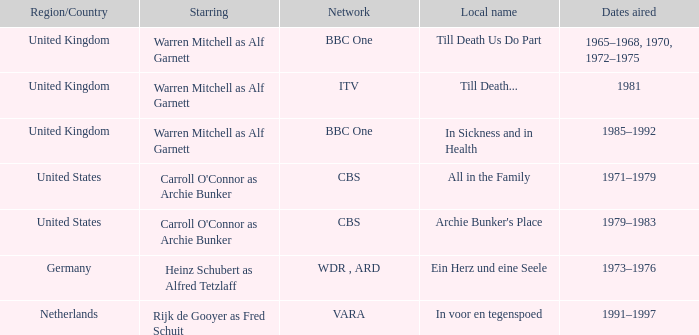What is the name of the network in the United Kingdom which aired in 1985–1992? BBC One. 